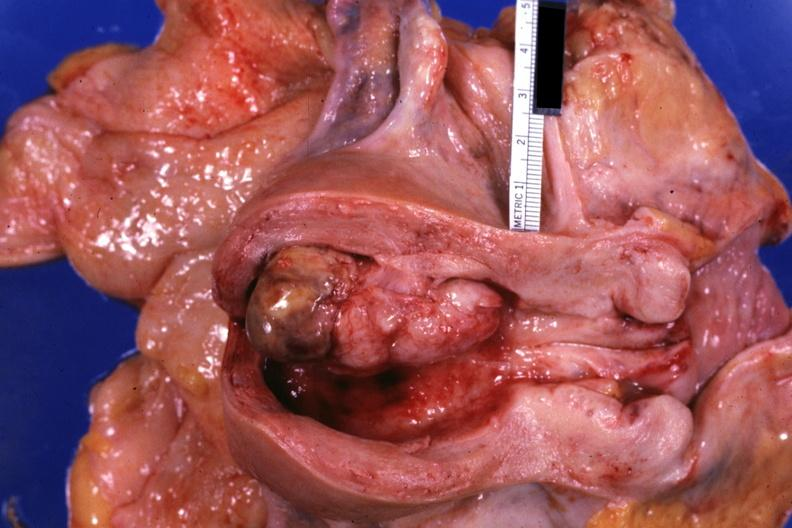s female reproductive present?
Answer the question using a single word or phrase. Yes 